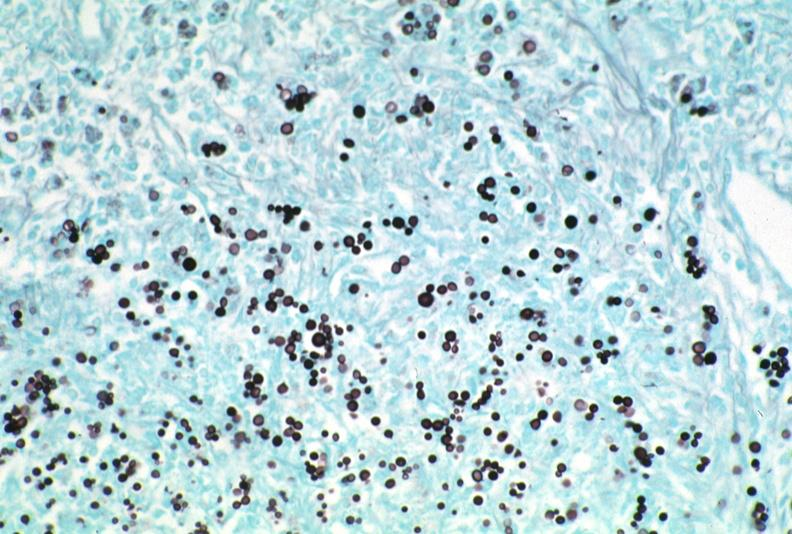does this image show lymph node, cryptococcosis gms?
Answer the question using a single word or phrase. Yes 